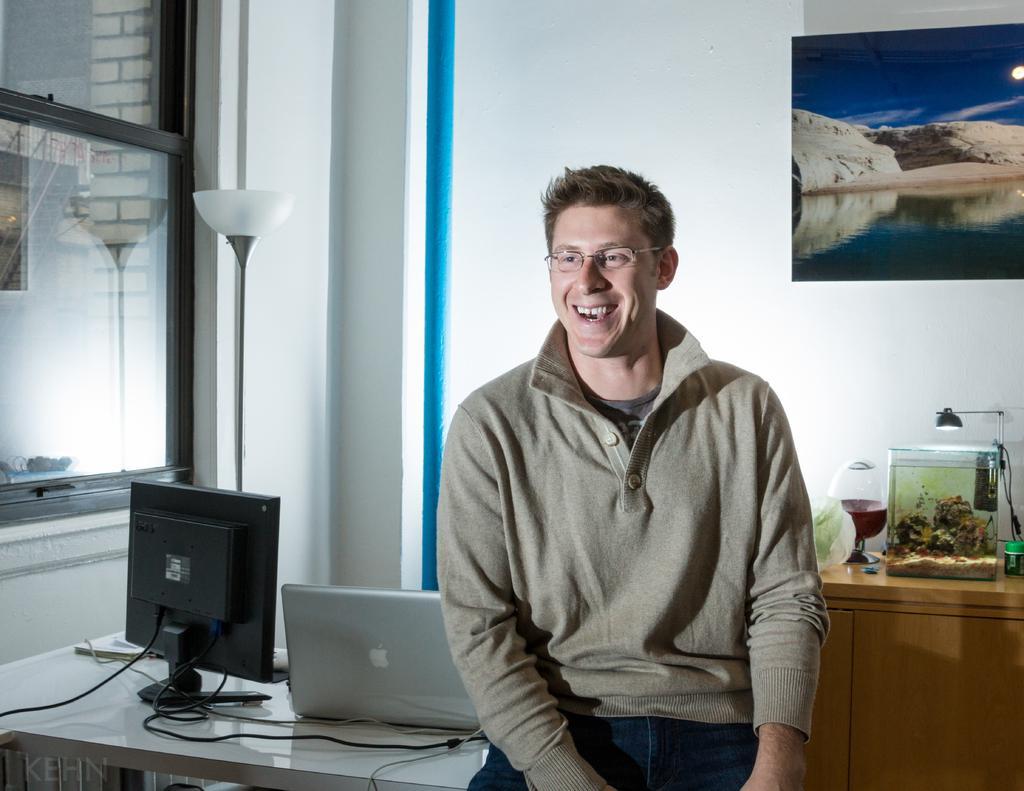Can you describe this image briefly? We can see a man sitting on a table behind him, laughing and there is a monitor and a laptop present on the table and at the right side we can see a glass and a box present and at the left side we can see a window and at the top right right we can see a picture present 